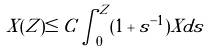<formula> <loc_0><loc_0><loc_500><loc_500>X ( Z ) \leq C \int _ { 0 } ^ { Z } ( 1 + s ^ { - 1 } ) X d s</formula> 